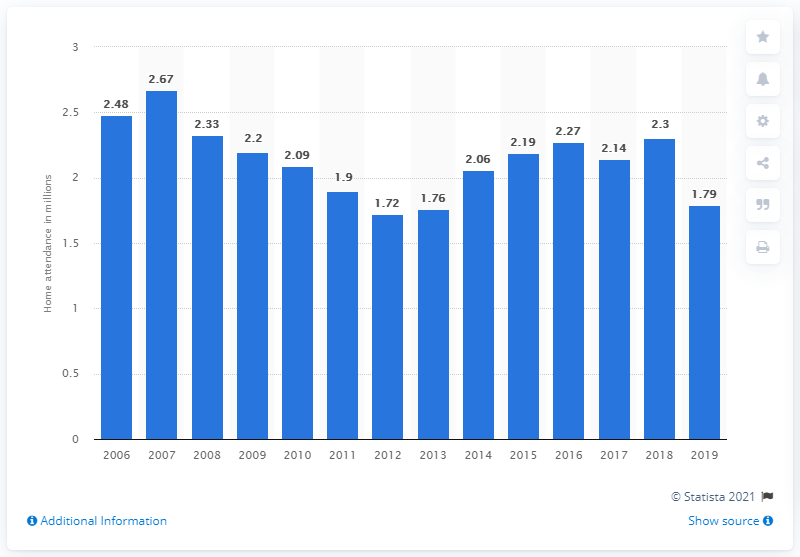Indicate a few pertinent items in this graphic. The regular season home attendance of the Seattle Mariners in 2019 was 1.79 million. 